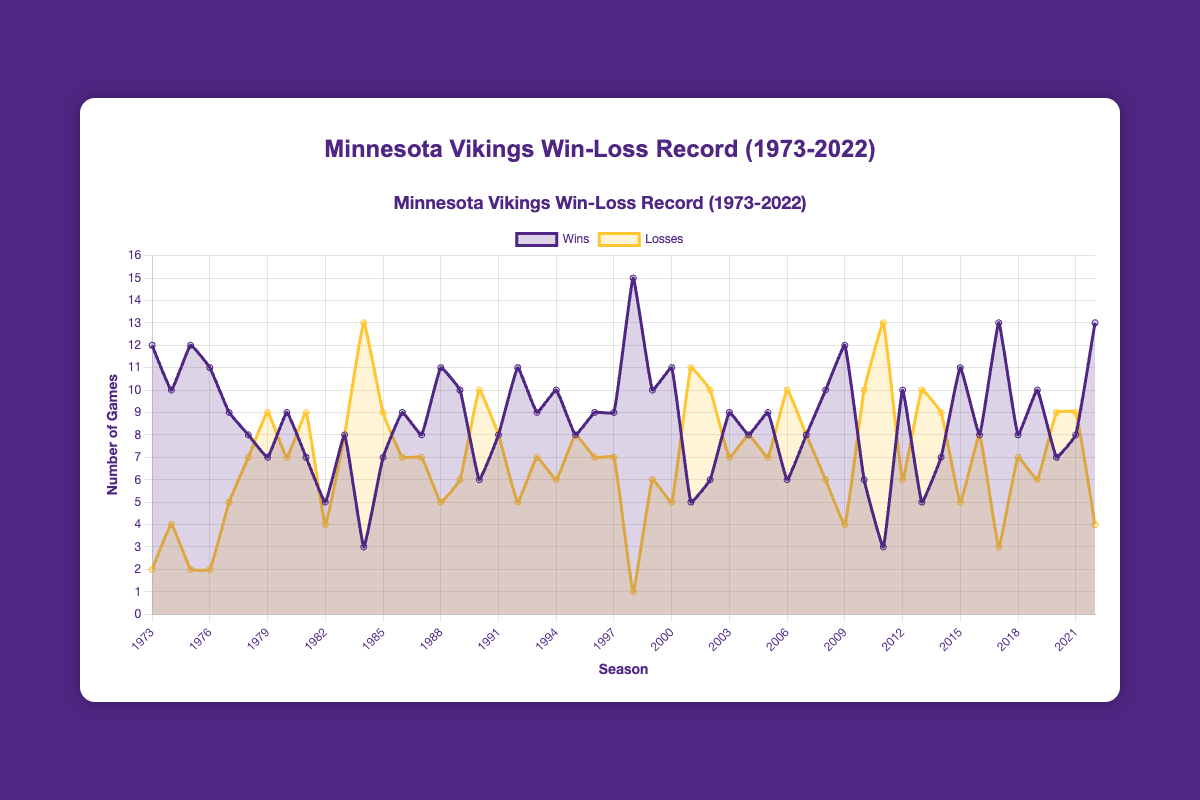Which season had the most wins for the Minnesota Vikings? The chart displays the wins for each season. The highest win total is 15, which occurred in 1998.
Answer: 1998 Which season had the most losses? By observing the losses over the years, the highest loss total is 13, occurring in both 1984 and 2011.
Answer: 1984 and 2011 How many seasons did the Vikings win 10 or more games? We need to count the number of seasons where the wins are 10 or more. These seasons are 1973, 1974, 1975, 1976, 1988, 1989, 1992, 1994, 1998, 1999, 2000, 2008, 2009, 2012, 2015, 2017, 2019, and 2022. There are 18 such seasons.
Answer: 18 In how many seasons did the Vikings have more losses than wins? Count the number of seasons where the loss total is greater than the win total. These seasons include 1979, 1981, 1984, 1990, 2001, 2002, 2006, 2010, 2011, 2013, 2014, and 2020, 2021. This gives us 13 seasons.
Answer: 13 What is the average number of wins per season over the 50 seasons? Sum all the win totals and divide by the number of seasons. The sum is 449 and the number of seasons is 50. So, the average is 449 / 50 = 8.98.
Answer: 8.98 Which decade had the highest average win rate? Calculate the average wins for each decade: 1970s (80/8 = 10), 1980s (78/10 = 7.8), 1990s (97/10 = 9.7), 2000s (98/10 = 9.8), 2010s (88/10 = 8.8), 2020s (28/3 = 9.33). The 1970s had the highest average.
Answer: 1970s In which season did the Vikings have an equal number of wins and losses? Looking at the chart, the season with an equal number of wins and losses is 1983.
Answer: 1983 Between 2000 and 2010, how many seasons had more than 9 wins? Check each season in the 2000 to 2010 range and count those with more than 9 wins. They are 2000, 2009 giving us 2 seasons.
Answer: 2 What was the total number of wins in the 1990s? Sum the wins from 1990 to 1999. This includes 6, 8, 11, 9, 10, 8, 9, 9, 15, and 10. The total is 6 + 8 + 11 + 9 + 10 + 8 + 9 + 9 + 15 + 10 = 95.
Answer: 95 Did the Vikings win more games in the 1980s or 2000s? Sum all wins in the 1980s (70) and 2000s (98) and compare. They won more games in the 2000s.
Answer: 2000s 